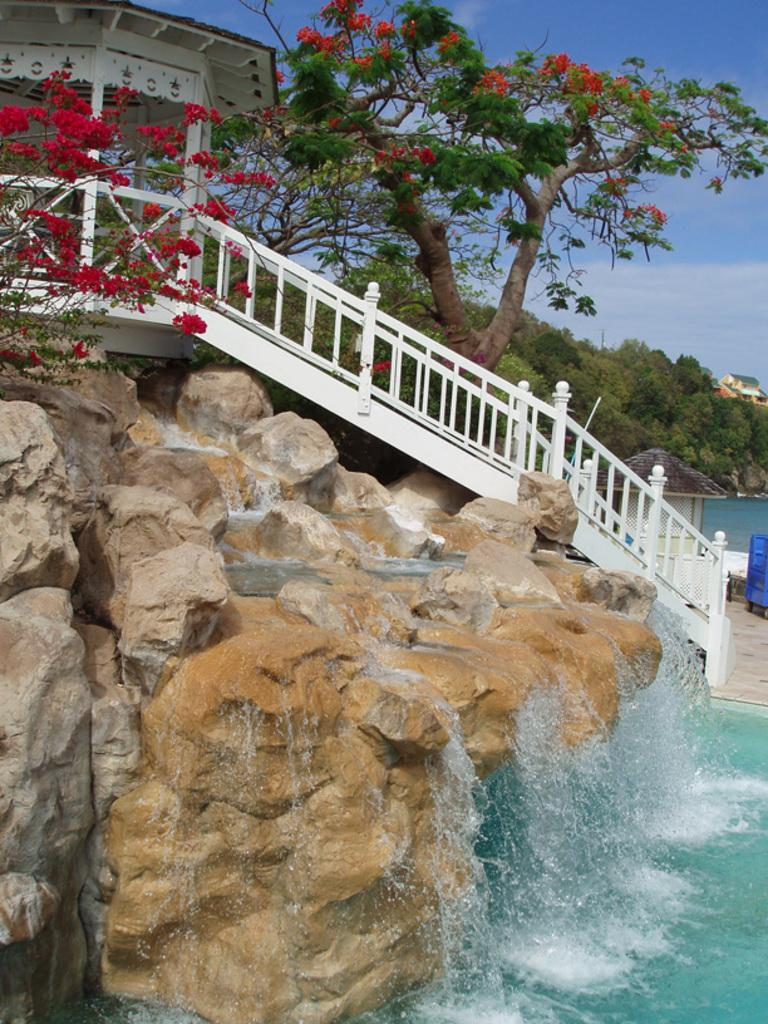What type of fence can be seen in the image? There is a white color fence in the image. What natural elements are present in the image? Rocks, flowers, and trees are visible in the image. What is the liquid element in the image? There is water in the image. What can be seen in the background of the image? Trees and the sky are visible in the background of the image. What type of list is being used by the fireman in the image? There is no fireman or list present in the image. How does the image help in measuring the distance between the rocks and the flowers? The image does not provide any tools or information for measuring distances; it is a visual representation of the scene. 